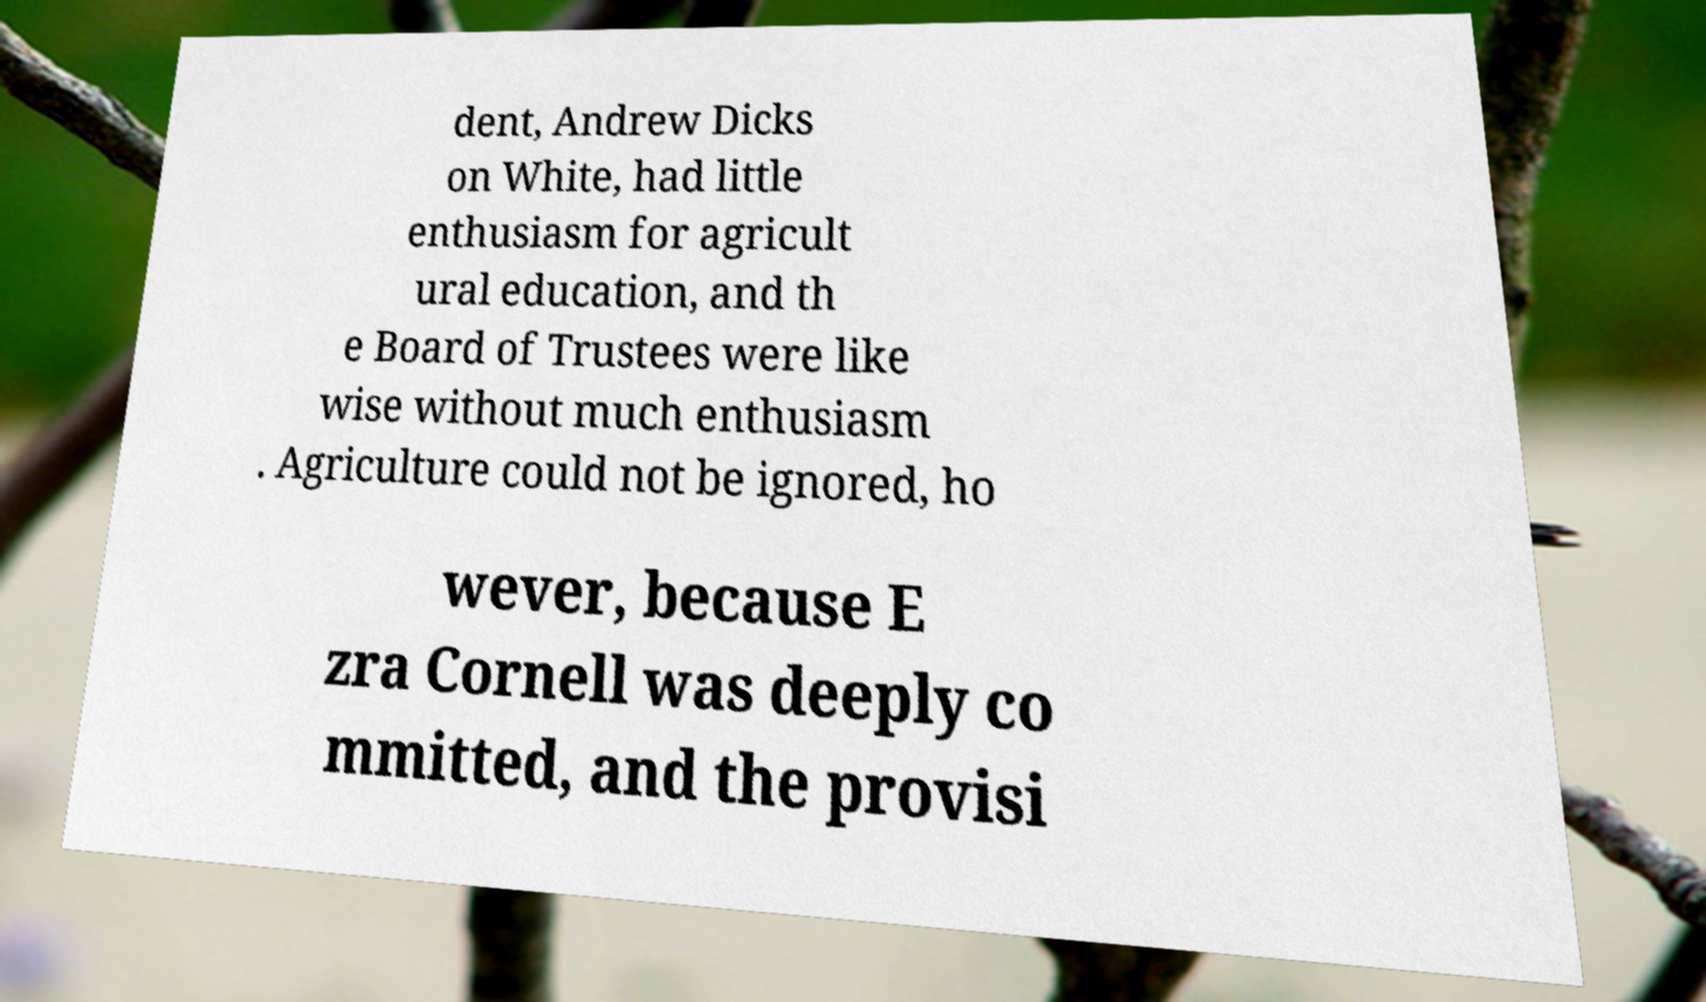For documentation purposes, I need the text within this image transcribed. Could you provide that? dent, Andrew Dicks on White, had little enthusiasm for agricult ural education, and th e Board of Trustees were like wise without much enthusiasm . Agriculture could not be ignored, ho wever, because E zra Cornell was deeply co mmitted, and the provisi 